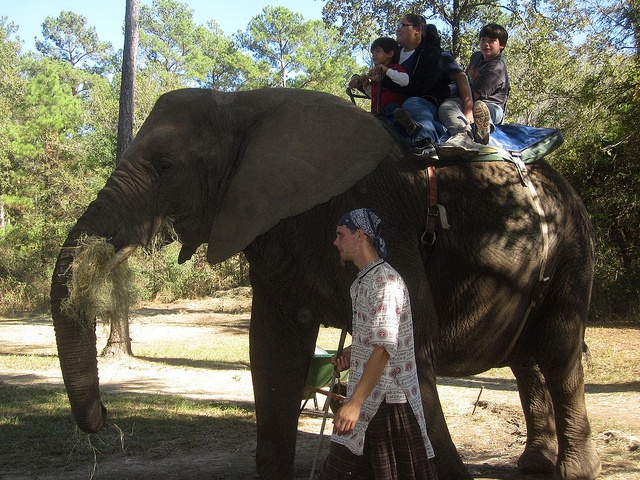Describe the objects in this image and their specific colors. I can see elephant in lightblue, black, and gray tones, people in lightblue, gray, black, and maroon tones, people in lightblue, black, gray, navy, and maroon tones, people in lightblue, black, gray, and maroon tones, and people in lightblue, black, gray, maroon, and darkgray tones in this image. 